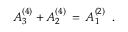Convert formula to latex. <formula><loc_0><loc_0><loc_500><loc_500>A _ { 3 } ^ { ( 4 ) } + A _ { 2 } ^ { ( 4 ) } \, = \, A _ { 1 } ^ { ( 2 ) } \, .</formula> 